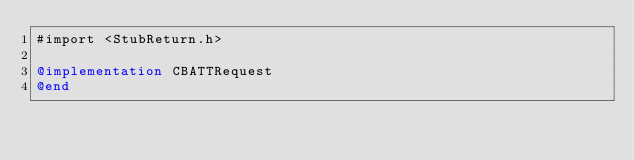Convert code to text. <code><loc_0><loc_0><loc_500><loc_500><_ObjectiveC_>#import <StubReturn.h>

@implementation CBATTRequest
@end
</code> 